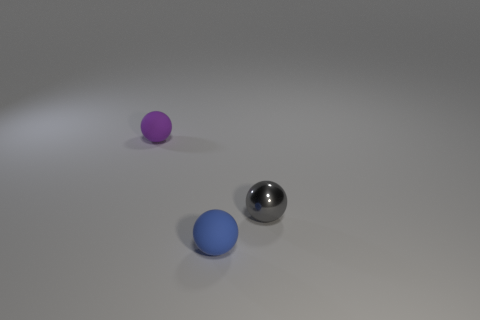What number of things are there?
Offer a very short reply. 3. How many cubes are either metal objects or purple matte things?
Provide a short and direct response. 0. How many tiny purple spheres are to the right of the tiny matte thing that is in front of the tiny matte sphere behind the small gray ball?
Ensure brevity in your answer.  0. What is the color of the other metallic thing that is the same size as the blue thing?
Keep it short and to the point. Gray. What number of other things are the same color as the tiny metal ball?
Your answer should be very brief. 0. Are there more gray objects on the left side of the small blue object than purple objects?
Ensure brevity in your answer.  No. Do the blue thing and the small purple ball have the same material?
Offer a terse response. Yes. What number of things are either tiny rubber balls that are in front of the purple sphere or small blue things?
Ensure brevity in your answer.  1. What number of other objects are the same size as the gray object?
Give a very brief answer. 2. Are there the same number of purple balls in front of the blue object and tiny purple matte things that are in front of the purple matte sphere?
Your response must be concise. Yes. 